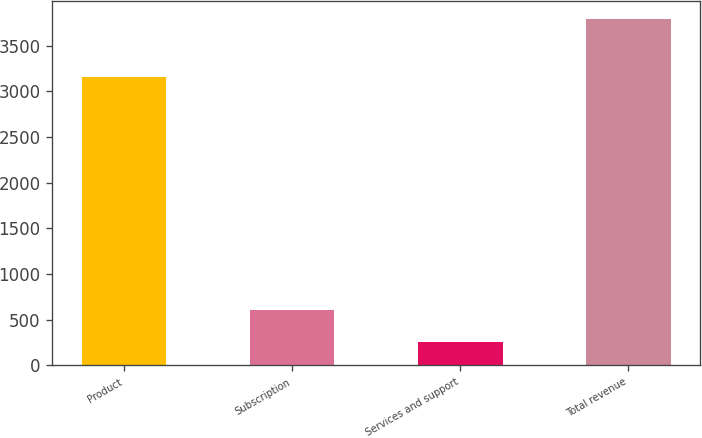<chart> <loc_0><loc_0><loc_500><loc_500><bar_chart><fcel>Product<fcel>Subscription<fcel>Services and support<fcel>Total revenue<nl><fcel>3159.2<fcel>608.6<fcel>254<fcel>3800<nl></chart> 